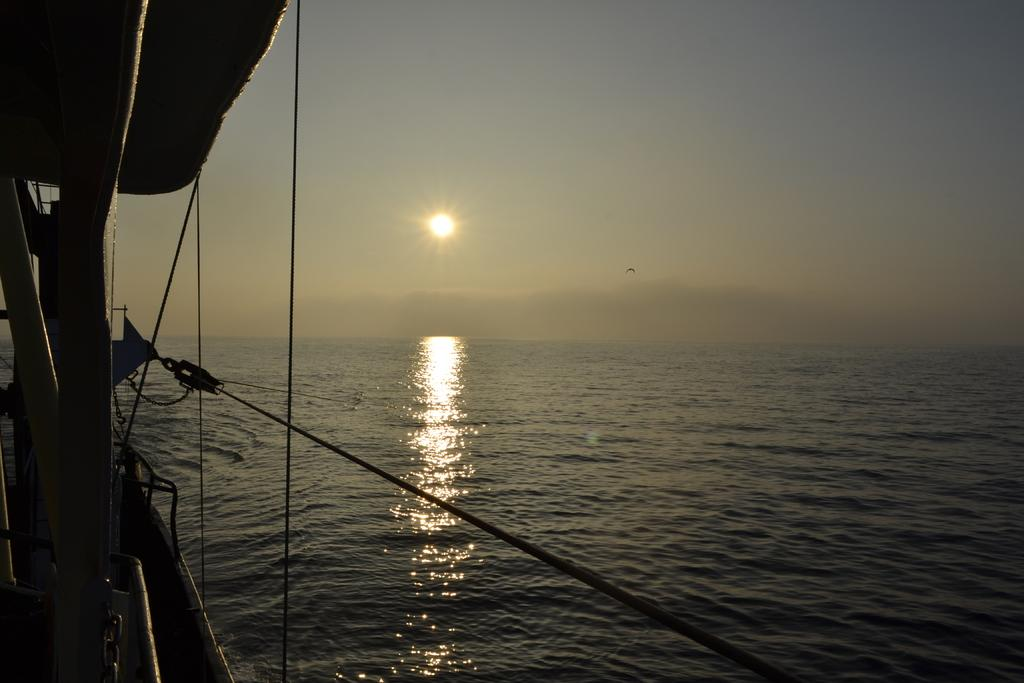What is located on the left side of the image? There is a boat on the left side of the image. What is connected to the boat? There are ropes associated with the boat. What can be seen in the background of the image? There is water visible in the background of the image. What is present at the top of the image? There is a bird and the sun visible at the top of the image. What else is visible at the top of the image? The sky is visible at the top of the image. What type of prison can be seen in the image? There is no prison present in the image; it features a boat, ropes, water, a bird, the sun, and the sky. How much debt is represented by the boat in the image? The image does not depict any debt; it shows a boat, ropes, water, a bird, the sun, and the sky. 